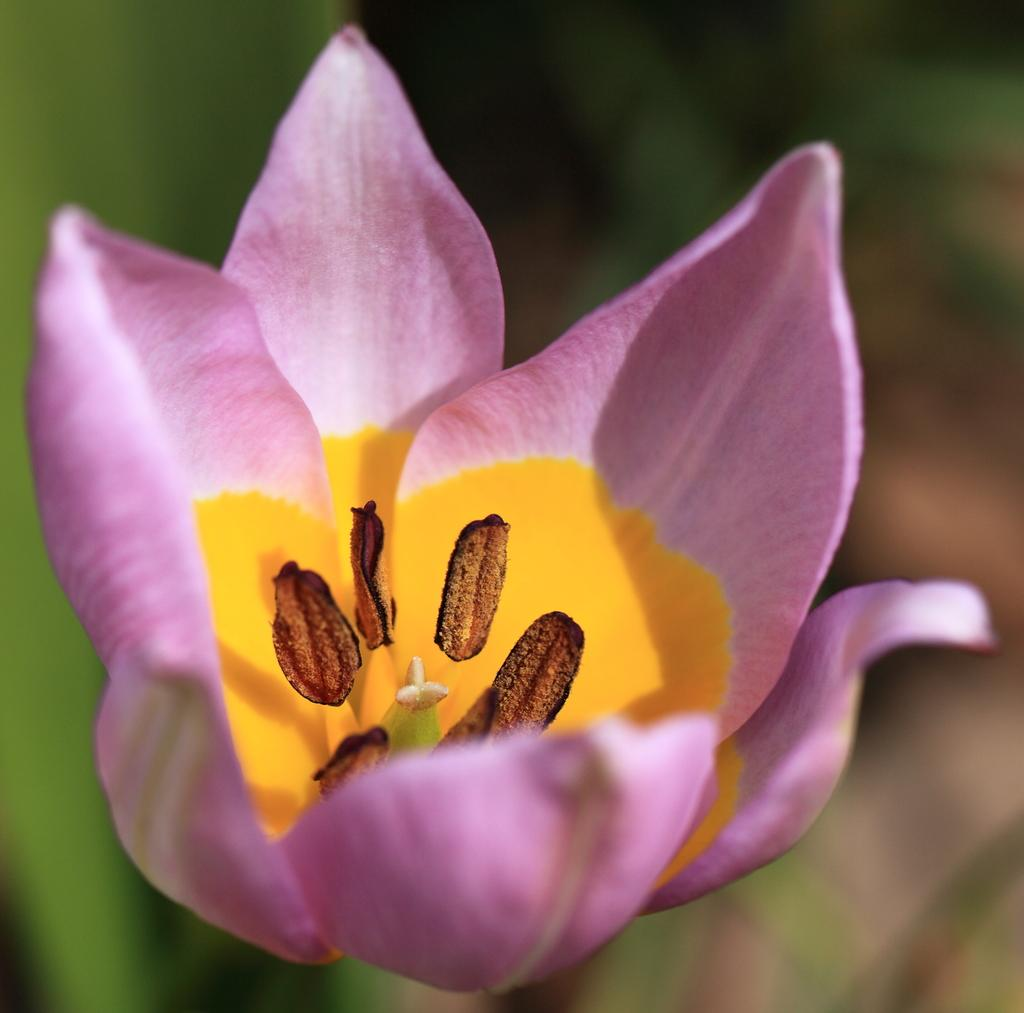What type of flower is in the image? There is a pink flower in the image. What part of the flower can be seen in the image? The flower's stamen is visible. How would you describe the background of the image? The background of the image is blurred. What color is the background? The background color is green. How does the rhythm of the feather affect the movement of the passenger in the image? There is no passenger or feather present in the image; it features a pink flower with a visible stamen against a green, blurred background. 